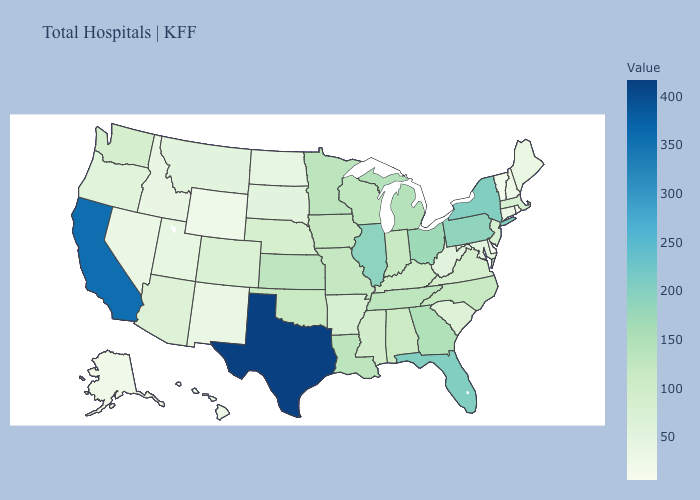Does Illinois have the lowest value in the MidWest?
Concise answer only. No. Which states hav the highest value in the Northeast?
Give a very brief answer. New York. Among the states that border Wisconsin , which have the lowest value?
Be succinct. Iowa. Among the states that border Connecticut , which have the highest value?
Short answer required. New York. Is the legend a continuous bar?
Write a very short answer. Yes. Which states have the highest value in the USA?
Keep it brief. Texas. Does Minnesota have a lower value than Illinois?
Write a very short answer. Yes. 